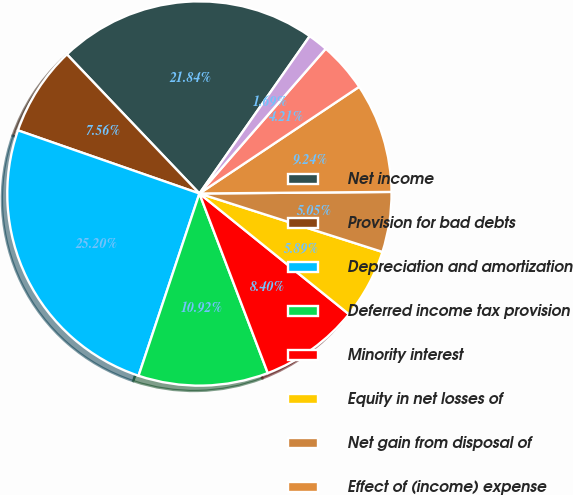Convert chart. <chart><loc_0><loc_0><loc_500><loc_500><pie_chart><fcel>Net income<fcel>Provision for bad debts<fcel>Depreciation and amortization<fcel>Deferred income tax provision<fcel>Minority interest<fcel>Equity in net losses of<fcel>Net gain from disposal of<fcel>Effect of (income) expense<fcel>Receivables<fcel>Other current assets<nl><fcel>21.84%<fcel>7.56%<fcel>25.2%<fcel>10.92%<fcel>8.4%<fcel>5.89%<fcel>5.05%<fcel>9.24%<fcel>4.21%<fcel>1.69%<nl></chart> 